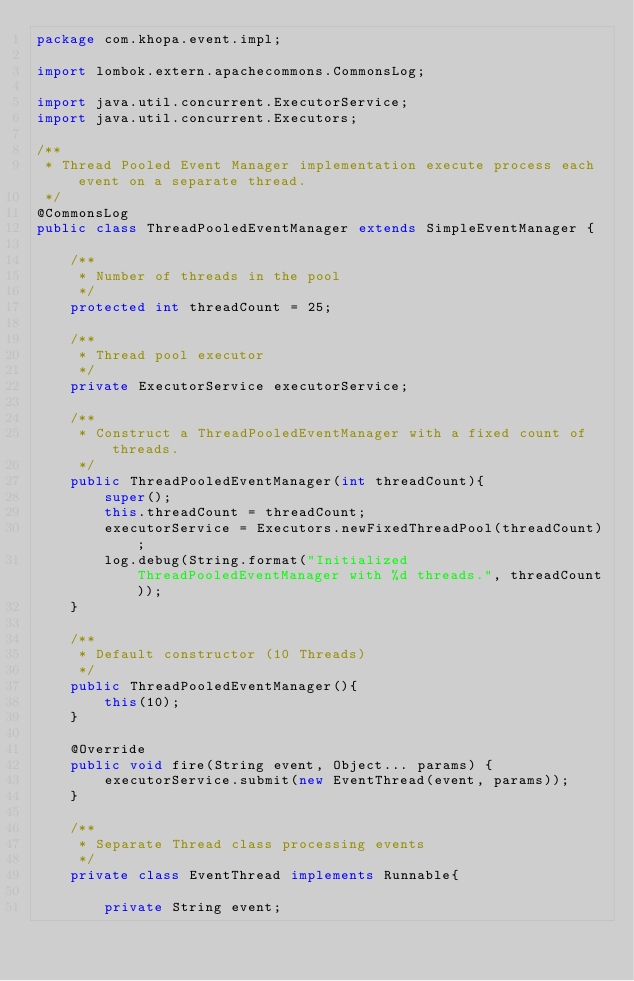<code> <loc_0><loc_0><loc_500><loc_500><_Java_>package com.khopa.event.impl;

import lombok.extern.apachecommons.CommonsLog;

import java.util.concurrent.ExecutorService;
import java.util.concurrent.Executors;

/**
 * Thread Pooled Event Manager implementation execute process each event on a separate thread.
 */
@CommonsLog
public class ThreadPooledEventManager extends SimpleEventManager {

    /**
     * Number of threads in the pool
     */
    protected int threadCount = 25;

    /**
     * Thread pool executor
     */
    private ExecutorService executorService;

    /**
     * Construct a ThreadPooledEventManager with a fixed count of threads.
     */
    public ThreadPooledEventManager(int threadCount){
        super();
        this.threadCount = threadCount;
        executorService = Executors.newFixedThreadPool(threadCount);
        log.debug(String.format("Initialized ThreadPooledEventManager with %d threads.", threadCount));
    }

    /**
     * Default constructor (10 Threads)
     */
    public ThreadPooledEventManager(){
        this(10);
    }

    @Override
    public void fire(String event, Object... params) {
        executorService.submit(new EventThread(event, params));
    }

    /**
     * Separate Thread class processing events
     */
    private class EventThread implements Runnable{

        private String event;</code> 